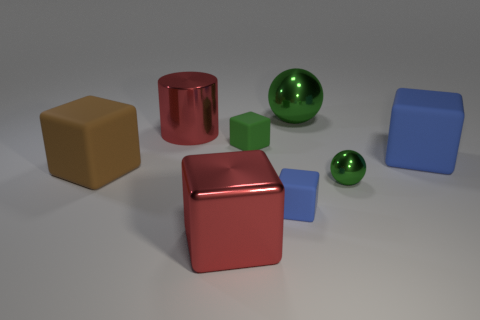What size is the cube that is the same color as the metal cylinder?
Provide a short and direct response. Large. Are there any other things that are made of the same material as the big red block?
Your answer should be very brief. Yes. There is a big red metal thing in front of the tiny green shiny object; is its shape the same as the large green metallic thing?
Your answer should be very brief. No. The metal thing in front of the small green ball is what color?
Your response must be concise. Red. There is a small object that is the same material as the large sphere; what is its shape?
Your answer should be compact. Sphere. Is there anything else that is the same color as the large ball?
Provide a short and direct response. Yes. Are there more tiny blue rubber blocks on the left side of the red metal cylinder than green shiny balls on the left side of the big red cube?
Your response must be concise. No. How many brown blocks have the same size as the green block?
Your answer should be very brief. 0. Is the number of small blue cubes in front of the large metallic block less than the number of small metal things that are in front of the brown rubber object?
Your response must be concise. Yes. Are there any small purple rubber objects that have the same shape as the brown thing?
Provide a succinct answer. No. 